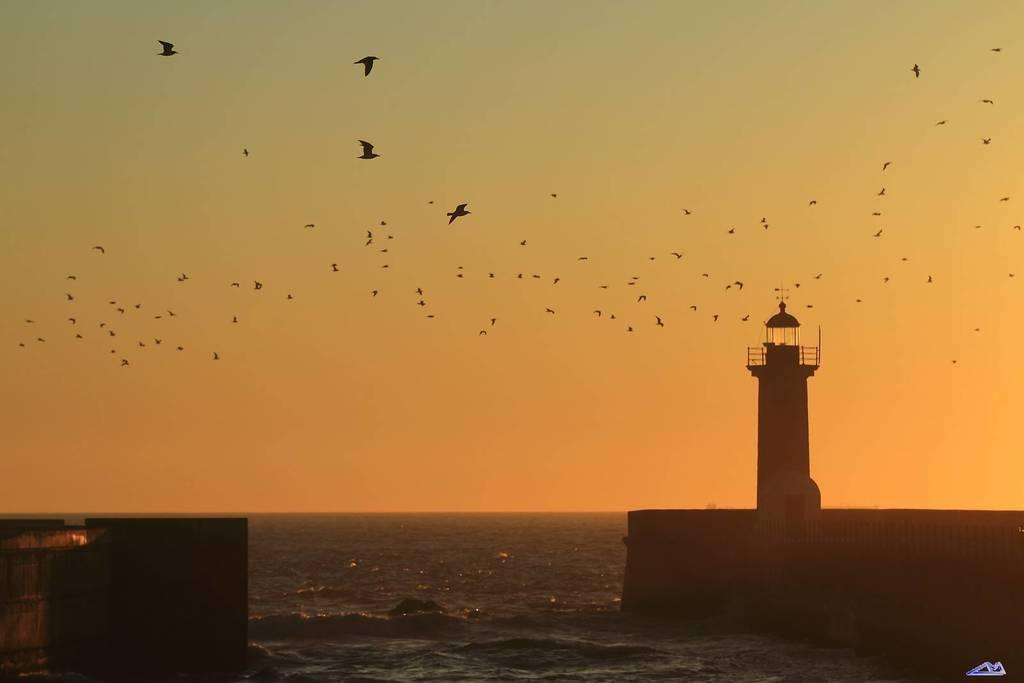What structure is located on the right side of the image? There is a tower on the right side of the image. What can be seen in the sky in the center of the image? There are birds in the sky in the center of the image. What is on the left side of the image? There is a dock on the left side of the image. Where is the snake located in the image? There is no snake present in the image. What type of hydrant can be seen near the dock in the image? There is no hydrant present in the image. 